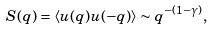Convert formula to latex. <formula><loc_0><loc_0><loc_500><loc_500>S ( q ) = \langle u ( q ) u ( - q ) \rangle \sim q ^ { - ( 1 - \gamma ) } ,</formula> 